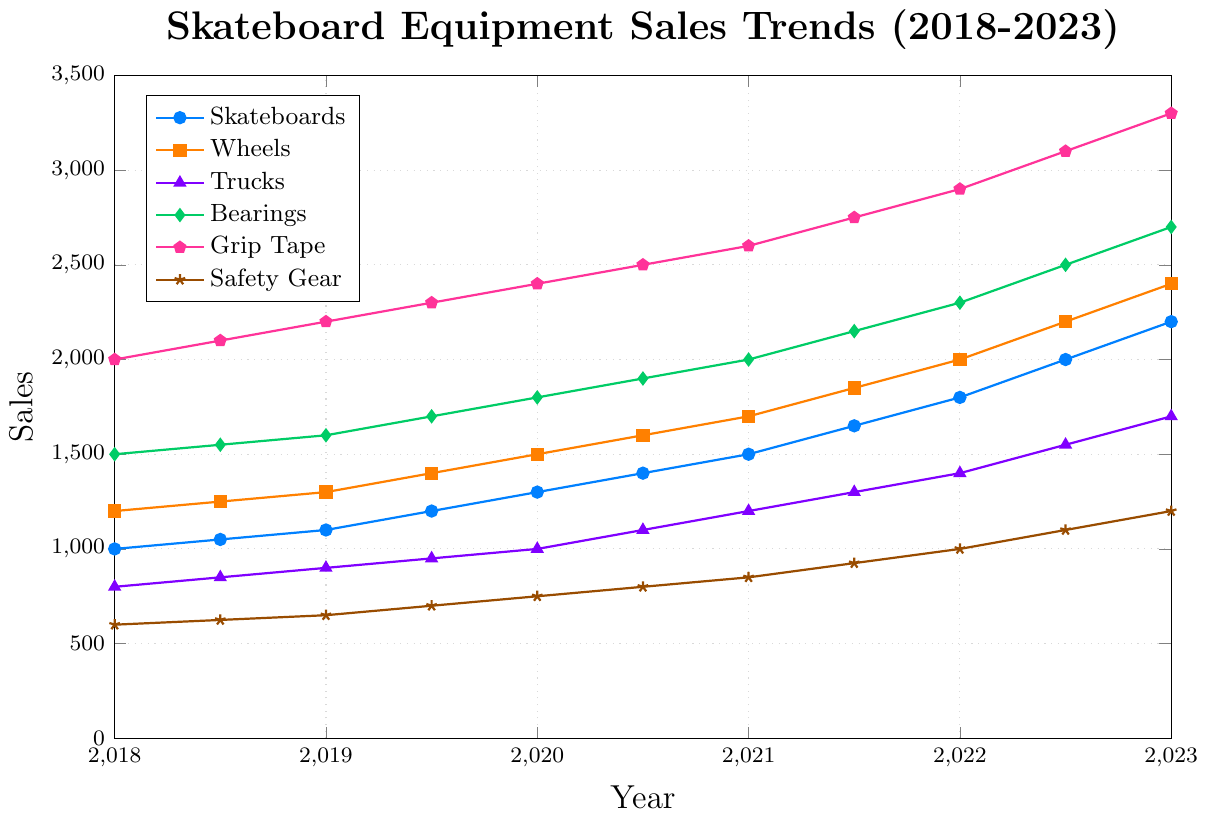What year did Grip Tape sales reach 2400? To find when Grip Tape sales hit 2400, follow the Grip Tape line and hover between the years on the x-axis. In 2020, the value reaches 2400.
Answer: 2020 Which product had the highest sales in 2023? Check the endpoints of all product lines at the year 2023 on the x-axis. Grip Tape reaches 3300, making it the product with the highest sales.
Answer: Grip Tape Which product showed the most consistent growth over the 5 years? Consistent growth would be indicated by a straight, increasing line. Skateboards show a nearly straight upward trend from 2018 to 2023.
Answer: Skateboards Between 2021 and 2022, which product's sales had the largest increase? Compare the lines' slopes between 2021 and 2022. Grip Tape's sales increased from 2600 to 2900, an increase of 300, which is larger than any other product.
Answer: Grip Tape What were the sales for Safety Gear in 2020.5? Follow the Safety Gear line (marked with stars) to 2020.5 on the x-axis. The value at this point is 800.
Answer: 800 Did Bearings ever surpass Wheels in sales? Compare the Bearings and Wheels lines across the timeline. Wheels are always higher, so Bearings never surpassed Wheels.
Answer: No At what time period did Skateboards experience their sharpest growth? Analyze the steepness of the Skateboards line. The sharpest growth is between 2021.5 and 2022.5, from 1650 to 2000 and then from 2000 to 2200.
Answer: 2021.5 to 2022.5 Which product had the lowest sales in 2019? Look at the values for all products at 2019 on the x-axis. Safety Gear has the lowest value at 650.
Answer: Safety Gear How much did the combined sales of Wheels and Trucks increase from 2018 to 2023? Find the values for each year and add them: Wheels started at 1200 and ended at 2400 (increase of 1200). Trucks started at 800 and ended at 1700 (increase of 900). Combined increase: 1200 + 900 = 2100.
Answer: 2100 By how much did Bearings sales grow from 2018.5 to 2021.5? Bearings sales went from 1550 in 2018.5 to 2150 in 2021.5. Subtract the initial value from the final value: 2150 - 1550 = 600.
Answer: 600 